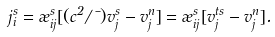<formula> <loc_0><loc_0><loc_500><loc_500>j _ { i } ^ { s } = \rho _ { i j } ^ { s } [ ( c ^ { 2 } / \mu ) v _ { j } ^ { s } - v _ { j } ^ { n } ] = \rho _ { i j } ^ { s } [ v _ { j } ^ { t s } - v _ { j } ^ { n } ] .</formula> 